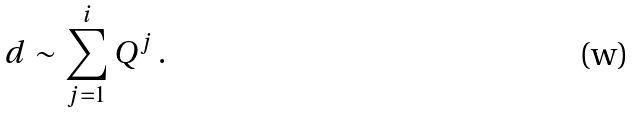<formula> <loc_0><loc_0><loc_500><loc_500>d \sim \sum _ { j = 1 } ^ { i } Q ^ { j } \, .</formula> 